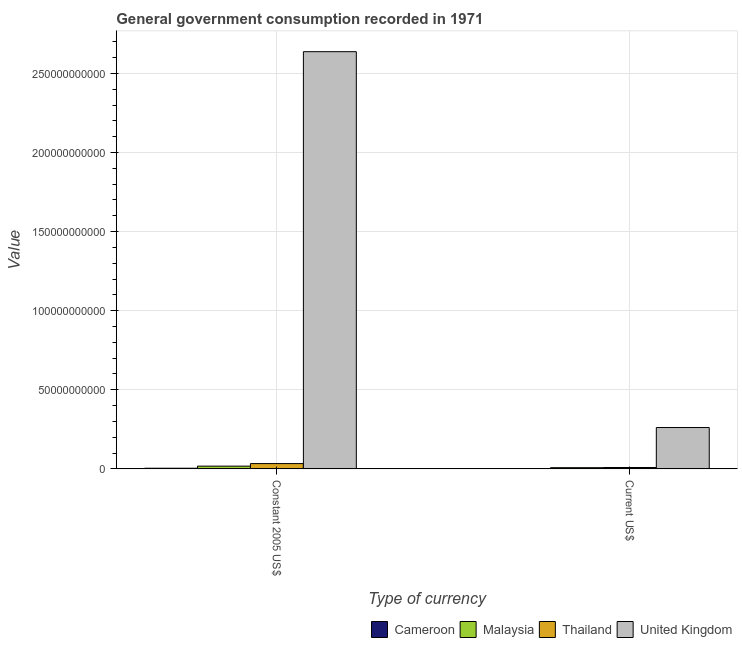How many different coloured bars are there?
Your answer should be compact. 4. Are the number of bars per tick equal to the number of legend labels?
Make the answer very short. Yes. Are the number of bars on each tick of the X-axis equal?
Your answer should be very brief. Yes. How many bars are there on the 2nd tick from the left?
Provide a succinct answer. 4. What is the label of the 2nd group of bars from the left?
Offer a very short reply. Current US$. What is the value consumed in constant 2005 us$ in Cameroon?
Offer a very short reply. 3.87e+08. Across all countries, what is the maximum value consumed in constant 2005 us$?
Provide a succinct answer. 2.64e+11. Across all countries, what is the minimum value consumed in current us$?
Your answer should be compact. 1.50e+08. In which country was the value consumed in constant 2005 us$ minimum?
Your answer should be very brief. Cameroon. What is the total value consumed in current us$ in the graph?
Your answer should be very brief. 2.79e+1. What is the difference between the value consumed in current us$ in Malaysia and that in United Kingdom?
Give a very brief answer. -2.54e+1. What is the difference between the value consumed in current us$ in Malaysia and the value consumed in constant 2005 us$ in Thailand?
Provide a succinct answer. -2.59e+09. What is the average value consumed in constant 2005 us$ per country?
Ensure brevity in your answer.  6.73e+1. What is the difference between the value consumed in constant 2005 us$ and value consumed in current us$ in Cameroon?
Provide a succinct answer. 2.37e+08. What is the ratio of the value consumed in constant 2005 us$ in Thailand to that in United Kingdom?
Your answer should be very brief. 0.01. Is the value consumed in current us$ in Thailand less than that in Cameroon?
Offer a very short reply. No. What does the 2nd bar from the left in Current US$ represents?
Your response must be concise. Malaysia. Are all the bars in the graph horizontal?
Your answer should be compact. No. How many countries are there in the graph?
Offer a very short reply. 4. What is the difference between two consecutive major ticks on the Y-axis?
Keep it short and to the point. 5.00e+1. Are the values on the major ticks of Y-axis written in scientific E-notation?
Ensure brevity in your answer.  No. Does the graph contain any zero values?
Your answer should be very brief. No. What is the title of the graph?
Your answer should be compact. General government consumption recorded in 1971. Does "Somalia" appear as one of the legend labels in the graph?
Keep it short and to the point. No. What is the label or title of the X-axis?
Keep it short and to the point. Type of currency. What is the label or title of the Y-axis?
Your answer should be very brief. Value. What is the Value of Cameroon in Constant 2005 US$?
Keep it short and to the point. 3.87e+08. What is the Value in Malaysia in Constant 2005 US$?
Offer a terse response. 1.72e+09. What is the Value of Thailand in Constant 2005 US$?
Your response must be concise. 3.32e+09. What is the Value of United Kingdom in Constant 2005 US$?
Give a very brief answer. 2.64e+11. What is the Value in Cameroon in Current US$?
Your response must be concise. 1.50e+08. What is the Value in Malaysia in Current US$?
Provide a succinct answer. 7.37e+08. What is the Value in Thailand in Current US$?
Offer a terse response. 8.50e+08. What is the Value in United Kingdom in Current US$?
Offer a terse response. 2.61e+1. Across all Type of currency, what is the maximum Value in Cameroon?
Your response must be concise. 3.87e+08. Across all Type of currency, what is the maximum Value of Malaysia?
Provide a short and direct response. 1.72e+09. Across all Type of currency, what is the maximum Value in Thailand?
Keep it short and to the point. 3.32e+09. Across all Type of currency, what is the maximum Value in United Kingdom?
Provide a succinct answer. 2.64e+11. Across all Type of currency, what is the minimum Value in Cameroon?
Make the answer very short. 1.50e+08. Across all Type of currency, what is the minimum Value of Malaysia?
Your answer should be very brief. 7.37e+08. Across all Type of currency, what is the minimum Value in Thailand?
Your answer should be very brief. 8.50e+08. Across all Type of currency, what is the minimum Value of United Kingdom?
Ensure brevity in your answer.  2.61e+1. What is the total Value of Cameroon in the graph?
Keep it short and to the point. 5.38e+08. What is the total Value in Malaysia in the graph?
Make the answer very short. 2.45e+09. What is the total Value of Thailand in the graph?
Give a very brief answer. 4.17e+09. What is the total Value of United Kingdom in the graph?
Keep it short and to the point. 2.90e+11. What is the difference between the Value in Cameroon in Constant 2005 US$ and that in Current US$?
Keep it short and to the point. 2.37e+08. What is the difference between the Value of Malaysia in Constant 2005 US$ and that in Current US$?
Offer a terse response. 9.80e+08. What is the difference between the Value in Thailand in Constant 2005 US$ and that in Current US$?
Keep it short and to the point. 2.47e+09. What is the difference between the Value in United Kingdom in Constant 2005 US$ and that in Current US$?
Your answer should be compact. 2.38e+11. What is the difference between the Value in Cameroon in Constant 2005 US$ and the Value in Malaysia in Current US$?
Provide a short and direct response. -3.50e+08. What is the difference between the Value of Cameroon in Constant 2005 US$ and the Value of Thailand in Current US$?
Ensure brevity in your answer.  -4.63e+08. What is the difference between the Value of Cameroon in Constant 2005 US$ and the Value of United Kingdom in Current US$?
Provide a short and direct response. -2.57e+1. What is the difference between the Value in Malaysia in Constant 2005 US$ and the Value in Thailand in Current US$?
Your answer should be compact. 8.68e+08. What is the difference between the Value of Malaysia in Constant 2005 US$ and the Value of United Kingdom in Current US$?
Offer a terse response. -2.44e+1. What is the difference between the Value of Thailand in Constant 2005 US$ and the Value of United Kingdom in Current US$?
Offer a terse response. -2.28e+1. What is the average Value of Cameroon per Type of currency?
Provide a succinct answer. 2.69e+08. What is the average Value of Malaysia per Type of currency?
Your answer should be very brief. 1.23e+09. What is the average Value of Thailand per Type of currency?
Provide a succinct answer. 2.09e+09. What is the average Value in United Kingdom per Type of currency?
Provide a succinct answer. 1.45e+11. What is the difference between the Value in Cameroon and Value in Malaysia in Constant 2005 US$?
Your answer should be very brief. -1.33e+09. What is the difference between the Value in Cameroon and Value in Thailand in Constant 2005 US$?
Give a very brief answer. -2.94e+09. What is the difference between the Value of Cameroon and Value of United Kingdom in Constant 2005 US$?
Offer a terse response. -2.63e+11. What is the difference between the Value of Malaysia and Value of Thailand in Constant 2005 US$?
Offer a terse response. -1.61e+09. What is the difference between the Value in Malaysia and Value in United Kingdom in Constant 2005 US$?
Provide a short and direct response. -2.62e+11. What is the difference between the Value of Thailand and Value of United Kingdom in Constant 2005 US$?
Your response must be concise. -2.60e+11. What is the difference between the Value of Cameroon and Value of Malaysia in Current US$?
Ensure brevity in your answer.  -5.87e+08. What is the difference between the Value in Cameroon and Value in Thailand in Current US$?
Provide a short and direct response. -6.99e+08. What is the difference between the Value in Cameroon and Value in United Kingdom in Current US$?
Offer a terse response. -2.60e+1. What is the difference between the Value in Malaysia and Value in Thailand in Current US$?
Provide a succinct answer. -1.12e+08. What is the difference between the Value of Malaysia and Value of United Kingdom in Current US$?
Your answer should be very brief. -2.54e+1. What is the difference between the Value of Thailand and Value of United Kingdom in Current US$?
Offer a terse response. -2.53e+1. What is the ratio of the Value of Cameroon in Constant 2005 US$ to that in Current US$?
Keep it short and to the point. 2.58. What is the ratio of the Value in Malaysia in Constant 2005 US$ to that in Current US$?
Provide a succinct answer. 2.33. What is the ratio of the Value in Thailand in Constant 2005 US$ to that in Current US$?
Your answer should be very brief. 3.91. What is the ratio of the Value of United Kingdom in Constant 2005 US$ to that in Current US$?
Your answer should be very brief. 10.09. What is the difference between the highest and the second highest Value of Cameroon?
Offer a very short reply. 2.37e+08. What is the difference between the highest and the second highest Value of Malaysia?
Your response must be concise. 9.80e+08. What is the difference between the highest and the second highest Value in Thailand?
Your answer should be very brief. 2.47e+09. What is the difference between the highest and the second highest Value of United Kingdom?
Your response must be concise. 2.38e+11. What is the difference between the highest and the lowest Value in Cameroon?
Give a very brief answer. 2.37e+08. What is the difference between the highest and the lowest Value of Malaysia?
Offer a terse response. 9.80e+08. What is the difference between the highest and the lowest Value in Thailand?
Provide a succinct answer. 2.47e+09. What is the difference between the highest and the lowest Value in United Kingdom?
Provide a short and direct response. 2.38e+11. 